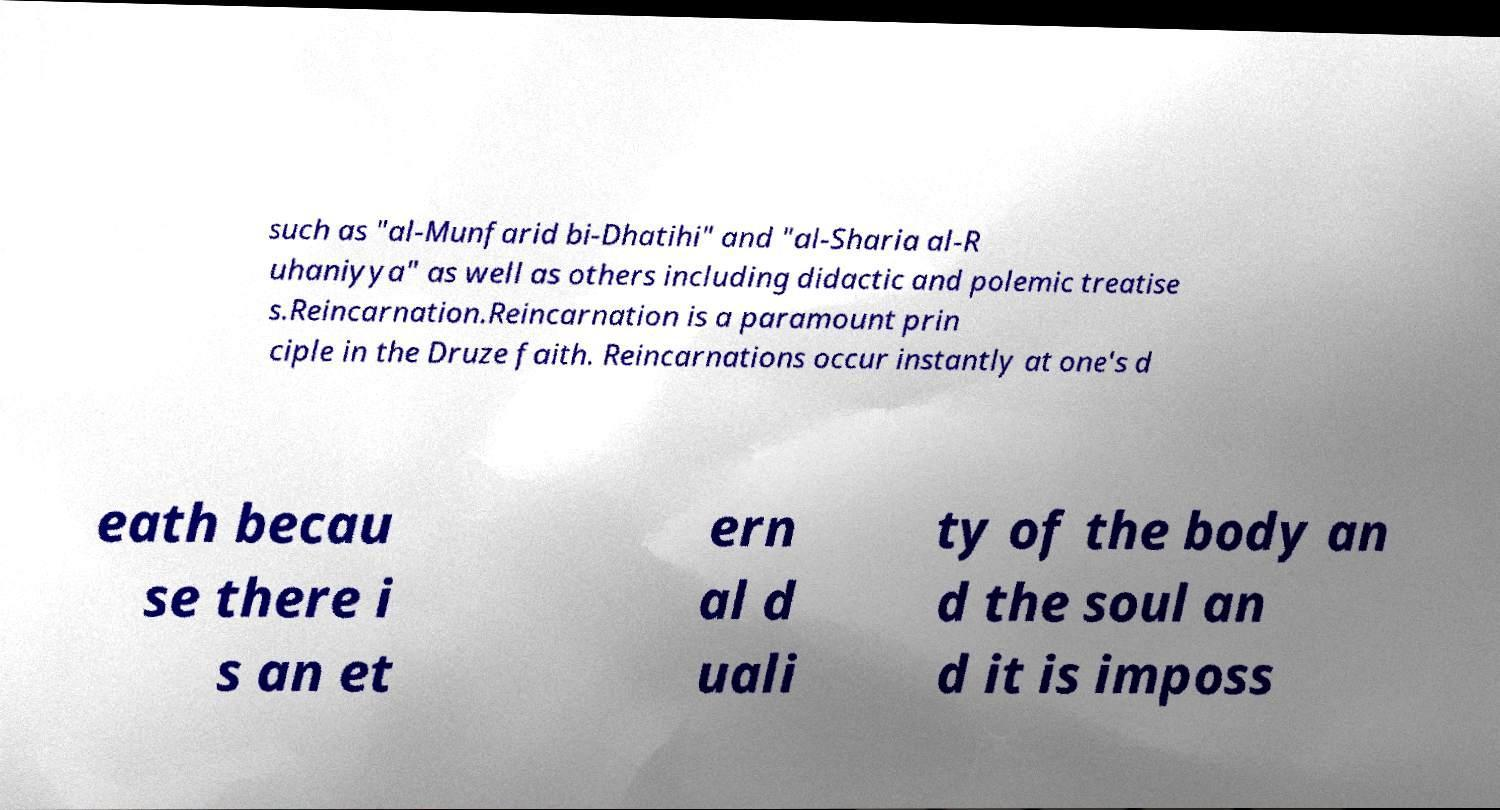There's text embedded in this image that I need extracted. Can you transcribe it verbatim? such as "al-Munfarid bi-Dhatihi" and "al-Sharia al-R uhaniyya" as well as others including didactic and polemic treatise s.Reincarnation.Reincarnation is a paramount prin ciple in the Druze faith. Reincarnations occur instantly at one's d eath becau se there i s an et ern al d uali ty of the body an d the soul an d it is imposs 